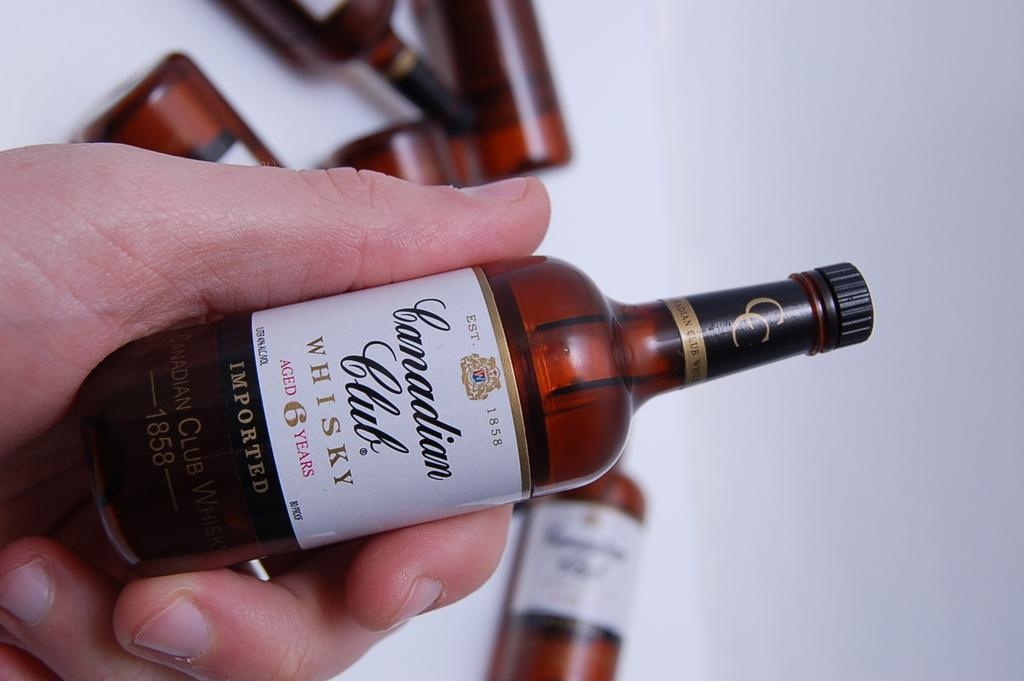Who or what is the main subject in the image? There is a person in the image. What is the person holding in his hand? The person is holding a small bottle in his hand. What can be seen in the background of the image? There is a white surface in the background of the image. How many bottles can be seen in the image besides the one held by the person? There are many more bottles visible in the image. What type of apple is sitting on the throne in the image? There is no apple or throne present in the image. 